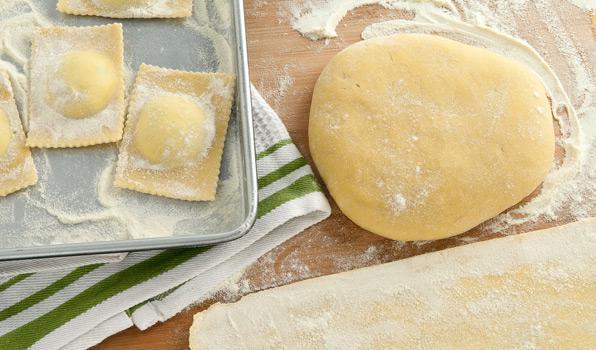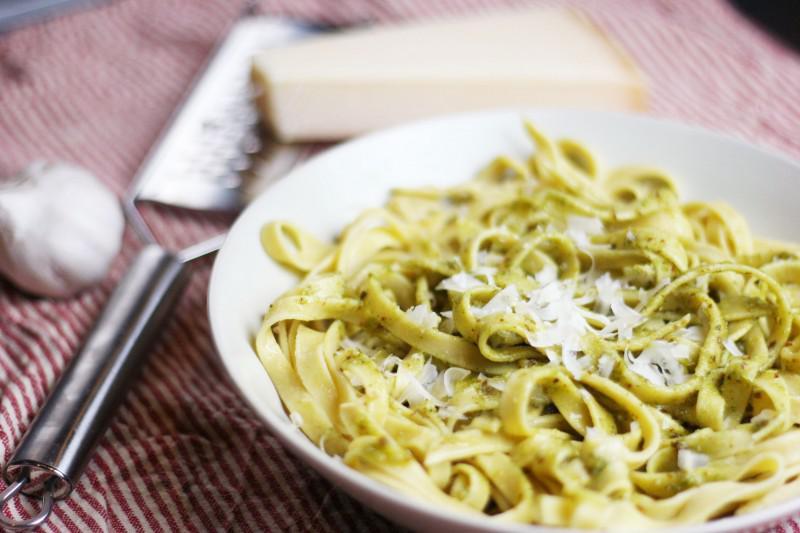The first image is the image on the left, the second image is the image on the right. Examine the images to the left and right. Is the description "A cooking instrument is seen on the table in one of the images." accurate? Answer yes or no. Yes. The first image is the image on the left, the second image is the image on the right. Given the left and right images, does the statement "One image includes a floured board and squarish pastries with mounded middles and scalloped edges, and the other image features noodles in a pile." hold true? Answer yes or no. Yes. 